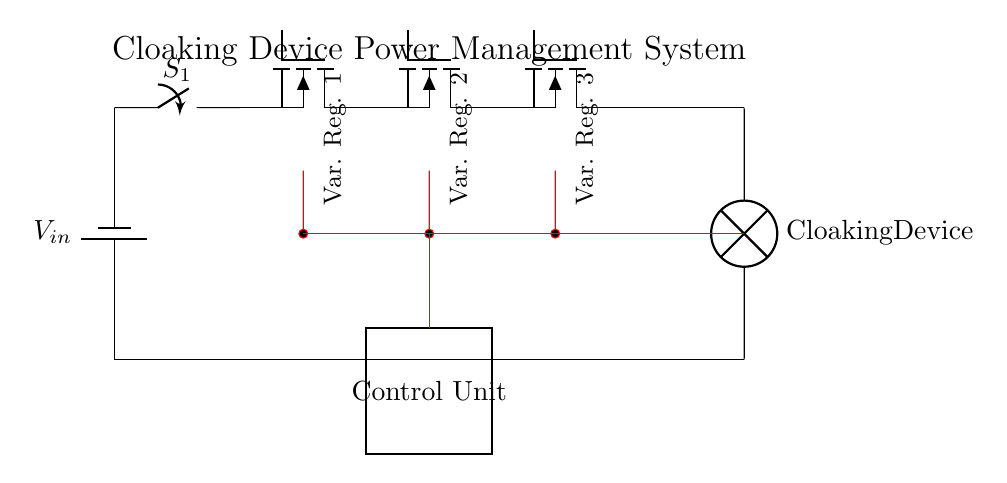What is the input voltage of this circuit? The input voltage is denoted by V_in. It is represented at the top of the circuit where the battery is connected, indicating it provides the necessary power for the entire arrangement.
Answer: V_in What type of load is connected in this circuit? The load connected is labeled as the "Cloaking Device," which indicates it is the device powered by the variable voltage regulators in the circuit. This load is represented by a lamp symbol at the bottom of the diagram.
Answer: Cloaking Device How many variable voltage regulators are present in the circuit? The circuit features three variable voltage regulators (VR1, VR2, and VR3), each marked accordingly in sequential order as depicted in the diagram.
Answer: 3 What does the red line in the circuit represent? The red lines represent the feedback and control signals that route back from the variable voltage regulators to the control unit. This setup enables the control unit to adjust the output voltage based on feedback, ensuring optimal operation of the cloaking device.
Answer: Feedback What is the function of the control unit in this circuit? The control unit is responsible for managing the output voltage from the variable voltage regulators based on the feedback signals. It allows for dynamic adjustments to meet the specific power needs of the cloaking device as portrayed in the diagram.
Answer: Power management Which component is responsible for switching the circuit on or off? The switch labeled S_1 is responsible for turning the circuit on or off, allowing control over the entire power flow from the battery to the load and regulators.
Answer: Switch 